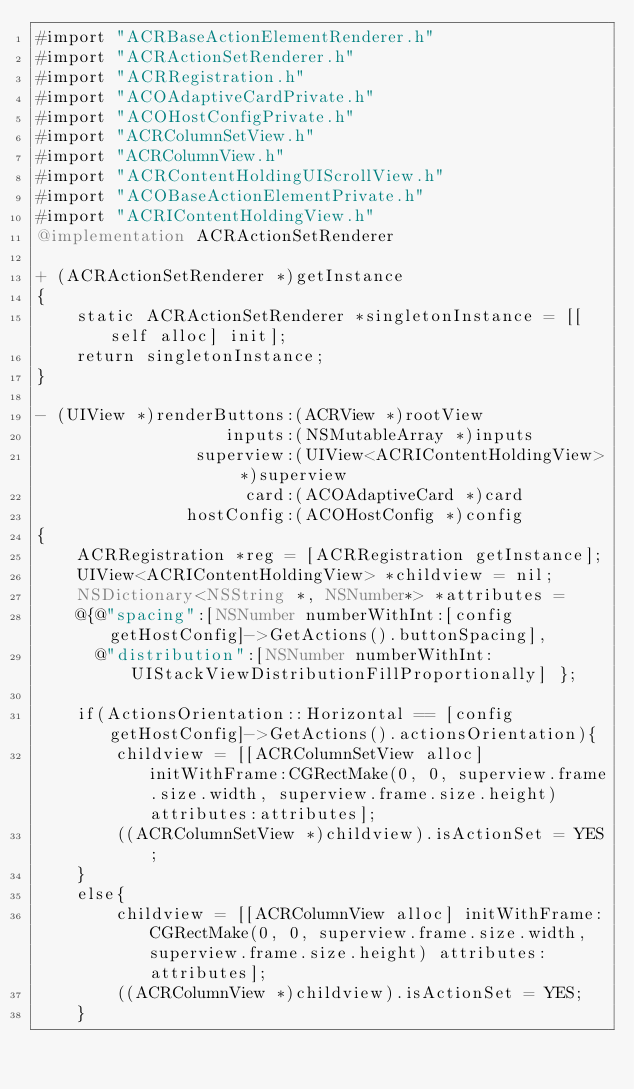Convert code to text. <code><loc_0><loc_0><loc_500><loc_500><_ObjectiveC_>#import "ACRBaseActionElementRenderer.h"
#import "ACRActionSetRenderer.h"
#import "ACRRegistration.h"
#import "ACOAdaptiveCardPrivate.h"
#import "ACOHostConfigPrivate.h"
#import "ACRColumnSetView.h"
#import "ACRColumnView.h"
#import "ACRContentHoldingUIScrollView.h"
#import "ACOBaseActionElementPrivate.h"
#import "ACRIContentHoldingView.h"
@implementation ACRActionSetRenderer

+ (ACRActionSetRenderer *)getInstance
{
    static ACRActionSetRenderer *singletonInstance = [[self alloc] init];
    return singletonInstance;
}

- (UIView *)renderButtons:(ACRView *)rootView
                   inputs:(NSMutableArray *)inputs
                superview:(UIView<ACRIContentHoldingView> *)superview
                     card:(ACOAdaptiveCard *)card
               hostConfig:(ACOHostConfig *)config
{
    ACRRegistration *reg = [ACRRegistration getInstance];
    UIView<ACRIContentHoldingView> *childview = nil;
    NSDictionary<NSString *, NSNumber*> *attributes =
    @{@"spacing":[NSNumber numberWithInt:[config getHostConfig]->GetActions().buttonSpacing],
      @"distribution":[NSNumber numberWithInt:UIStackViewDistributionFillProportionally] };

    if(ActionsOrientation::Horizontal == [config getHostConfig]->GetActions().actionsOrientation){
        childview = [[ACRColumnSetView alloc] initWithFrame:CGRectMake(0, 0, superview.frame.size.width, superview.frame.size.height) attributes:attributes];
        ((ACRColumnSetView *)childview).isActionSet = YES;
    }
    else{
        childview = [[ACRColumnView alloc] initWithFrame:CGRectMake(0, 0, superview.frame.size.width, superview.frame.size.height) attributes:attributes];
        ((ACRColumnView *)childview).isActionSet = YES;
    }
</code> 